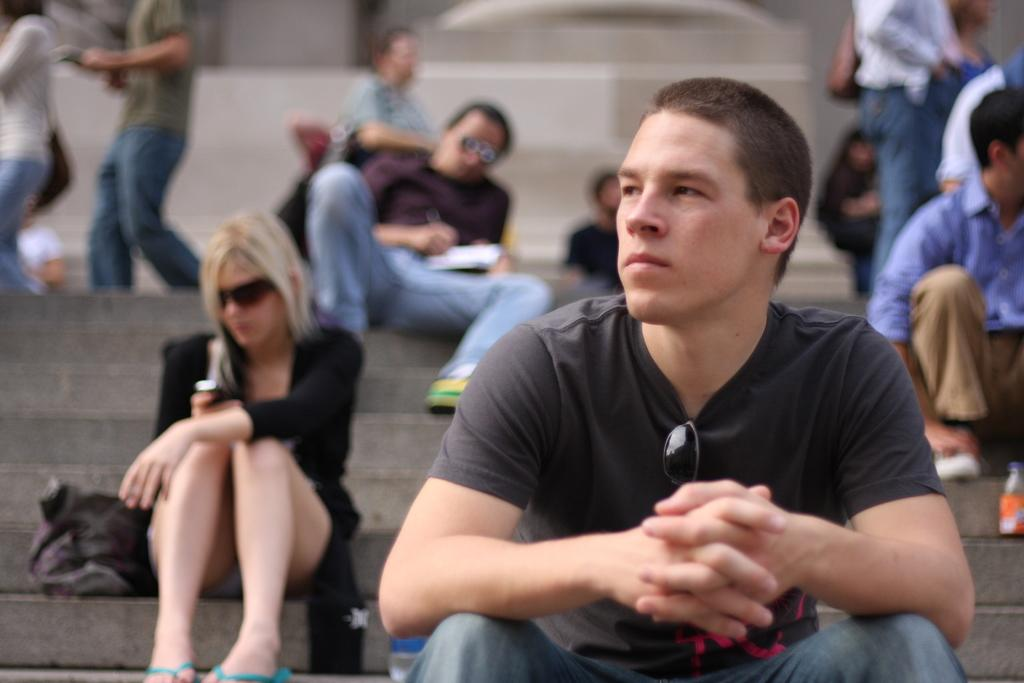What is the main subject in the foreground of the image? There is a man sitting in the foreground of the image. What can be seen in the background of the image? There are people sitting on the stairs in the background of the image. What type of attack is being carried out by the duck in the image? There is no duck present in the image, so no attack can be observed. 